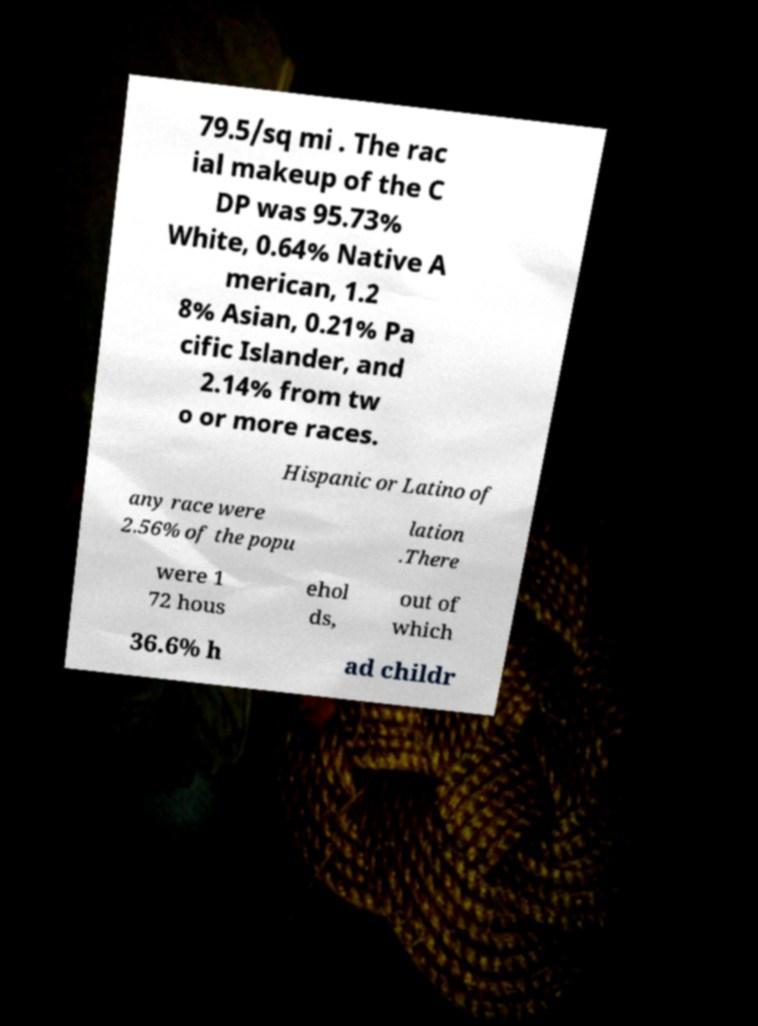Could you extract and type out the text from this image? 79.5/sq mi . The rac ial makeup of the C DP was 95.73% White, 0.64% Native A merican, 1.2 8% Asian, 0.21% Pa cific Islander, and 2.14% from tw o or more races. Hispanic or Latino of any race were 2.56% of the popu lation .There were 1 72 hous ehol ds, out of which 36.6% h ad childr 